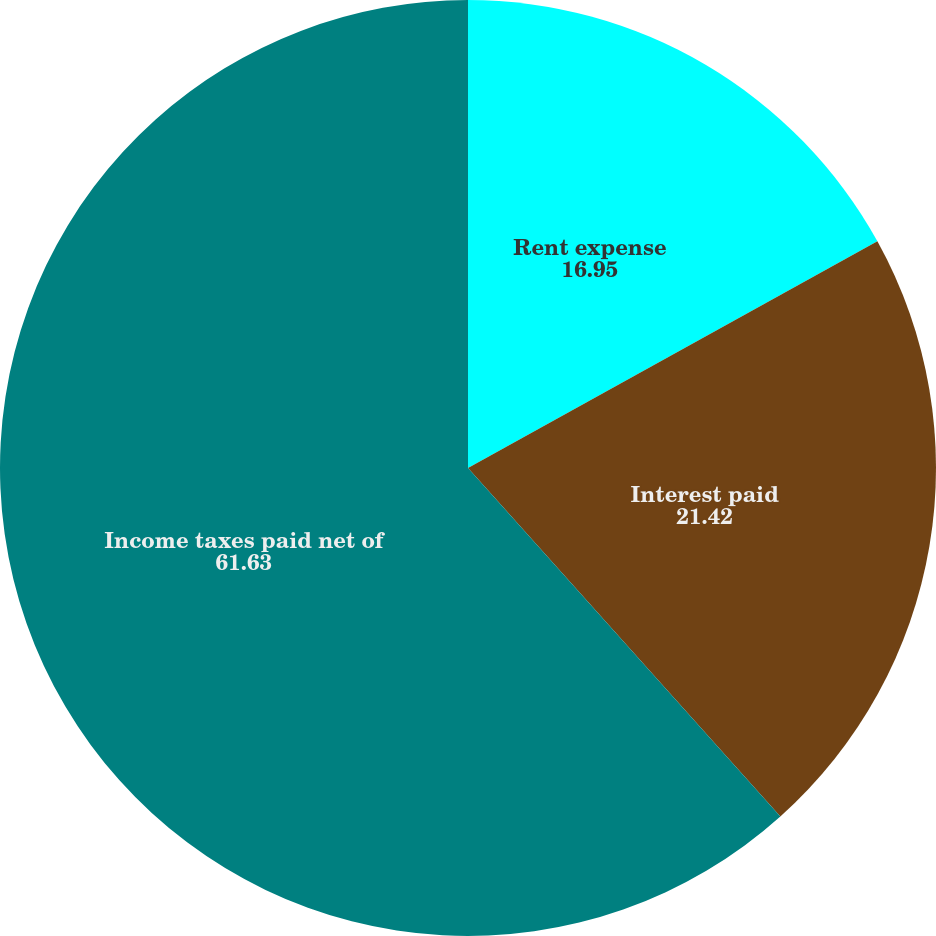<chart> <loc_0><loc_0><loc_500><loc_500><pie_chart><fcel>Rent expense<fcel>Interest paid<fcel>Income taxes paid net of<nl><fcel>16.95%<fcel>21.42%<fcel>61.63%<nl></chart> 